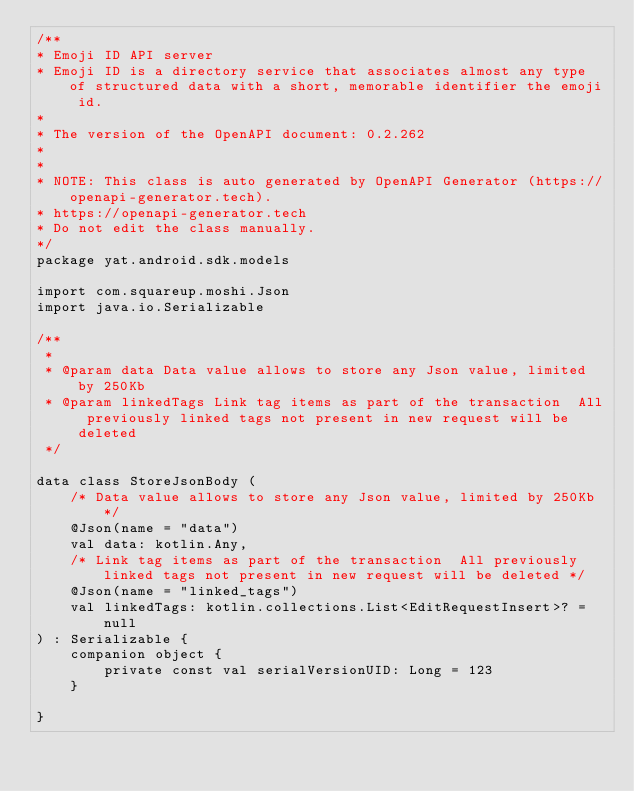Convert code to text. <code><loc_0><loc_0><loc_500><loc_500><_Kotlin_>/**
* Emoji ID API server
* Emoji ID is a directory service that associates almost any type of structured data with a short, memorable identifier the emoji id.
*
* The version of the OpenAPI document: 0.2.262
* 
*
* NOTE: This class is auto generated by OpenAPI Generator (https://openapi-generator.tech).
* https://openapi-generator.tech
* Do not edit the class manually.
*/
package yat.android.sdk.models

import com.squareup.moshi.Json
import java.io.Serializable

/**
 * 
 * @param data Data value allows to store any Json value, limited by 250Kb
 * @param linkedTags Link tag items as part of the transaction  All previously linked tags not present in new request will be deleted
 */

data class StoreJsonBody (
    /* Data value allows to store any Json value, limited by 250Kb */
    @Json(name = "data")
    val data: kotlin.Any,
    /* Link tag items as part of the transaction  All previously linked tags not present in new request will be deleted */
    @Json(name = "linked_tags")
    val linkedTags: kotlin.collections.List<EditRequestInsert>? = null
) : Serializable {
    companion object {
        private const val serialVersionUID: Long = 123
    }

}

</code> 